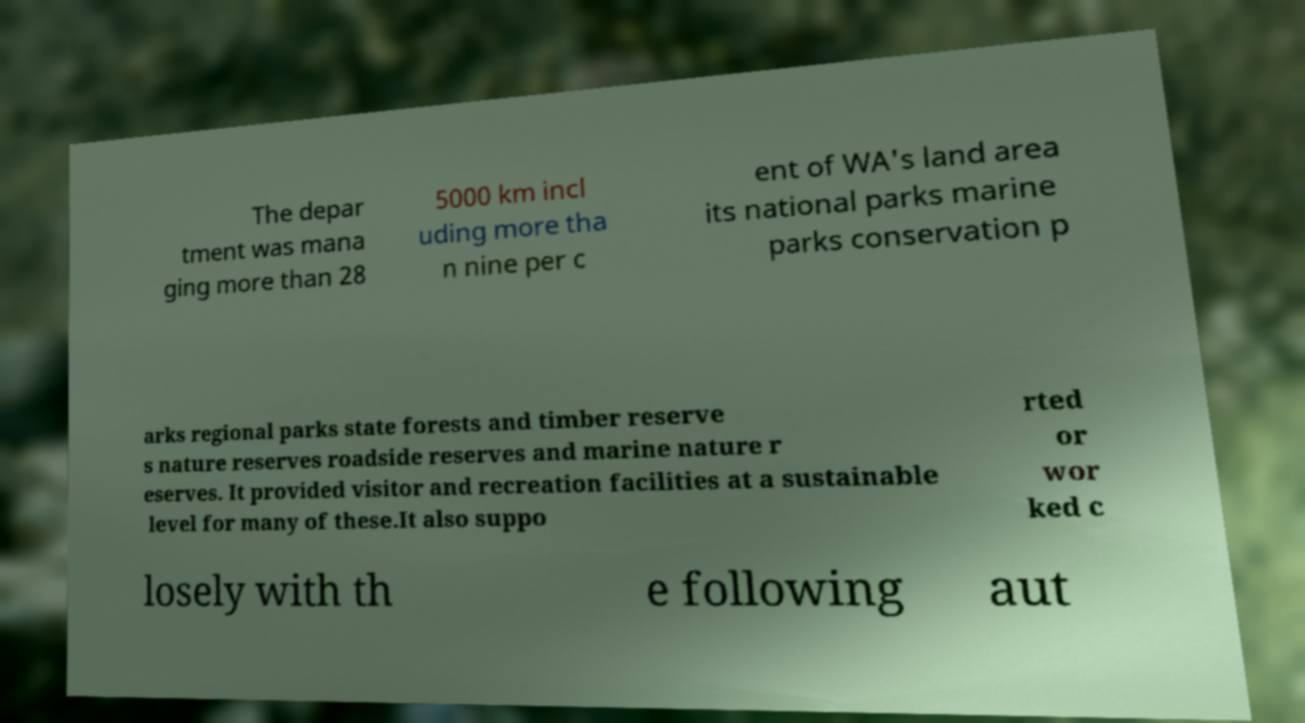There's text embedded in this image that I need extracted. Can you transcribe it verbatim? The depar tment was mana ging more than 28 5000 km incl uding more tha n nine per c ent of WA's land area its national parks marine parks conservation p arks regional parks state forests and timber reserve s nature reserves roadside reserves and marine nature r eserves. It provided visitor and recreation facilities at a sustainable level for many of these.It also suppo rted or wor ked c losely with th e following aut 